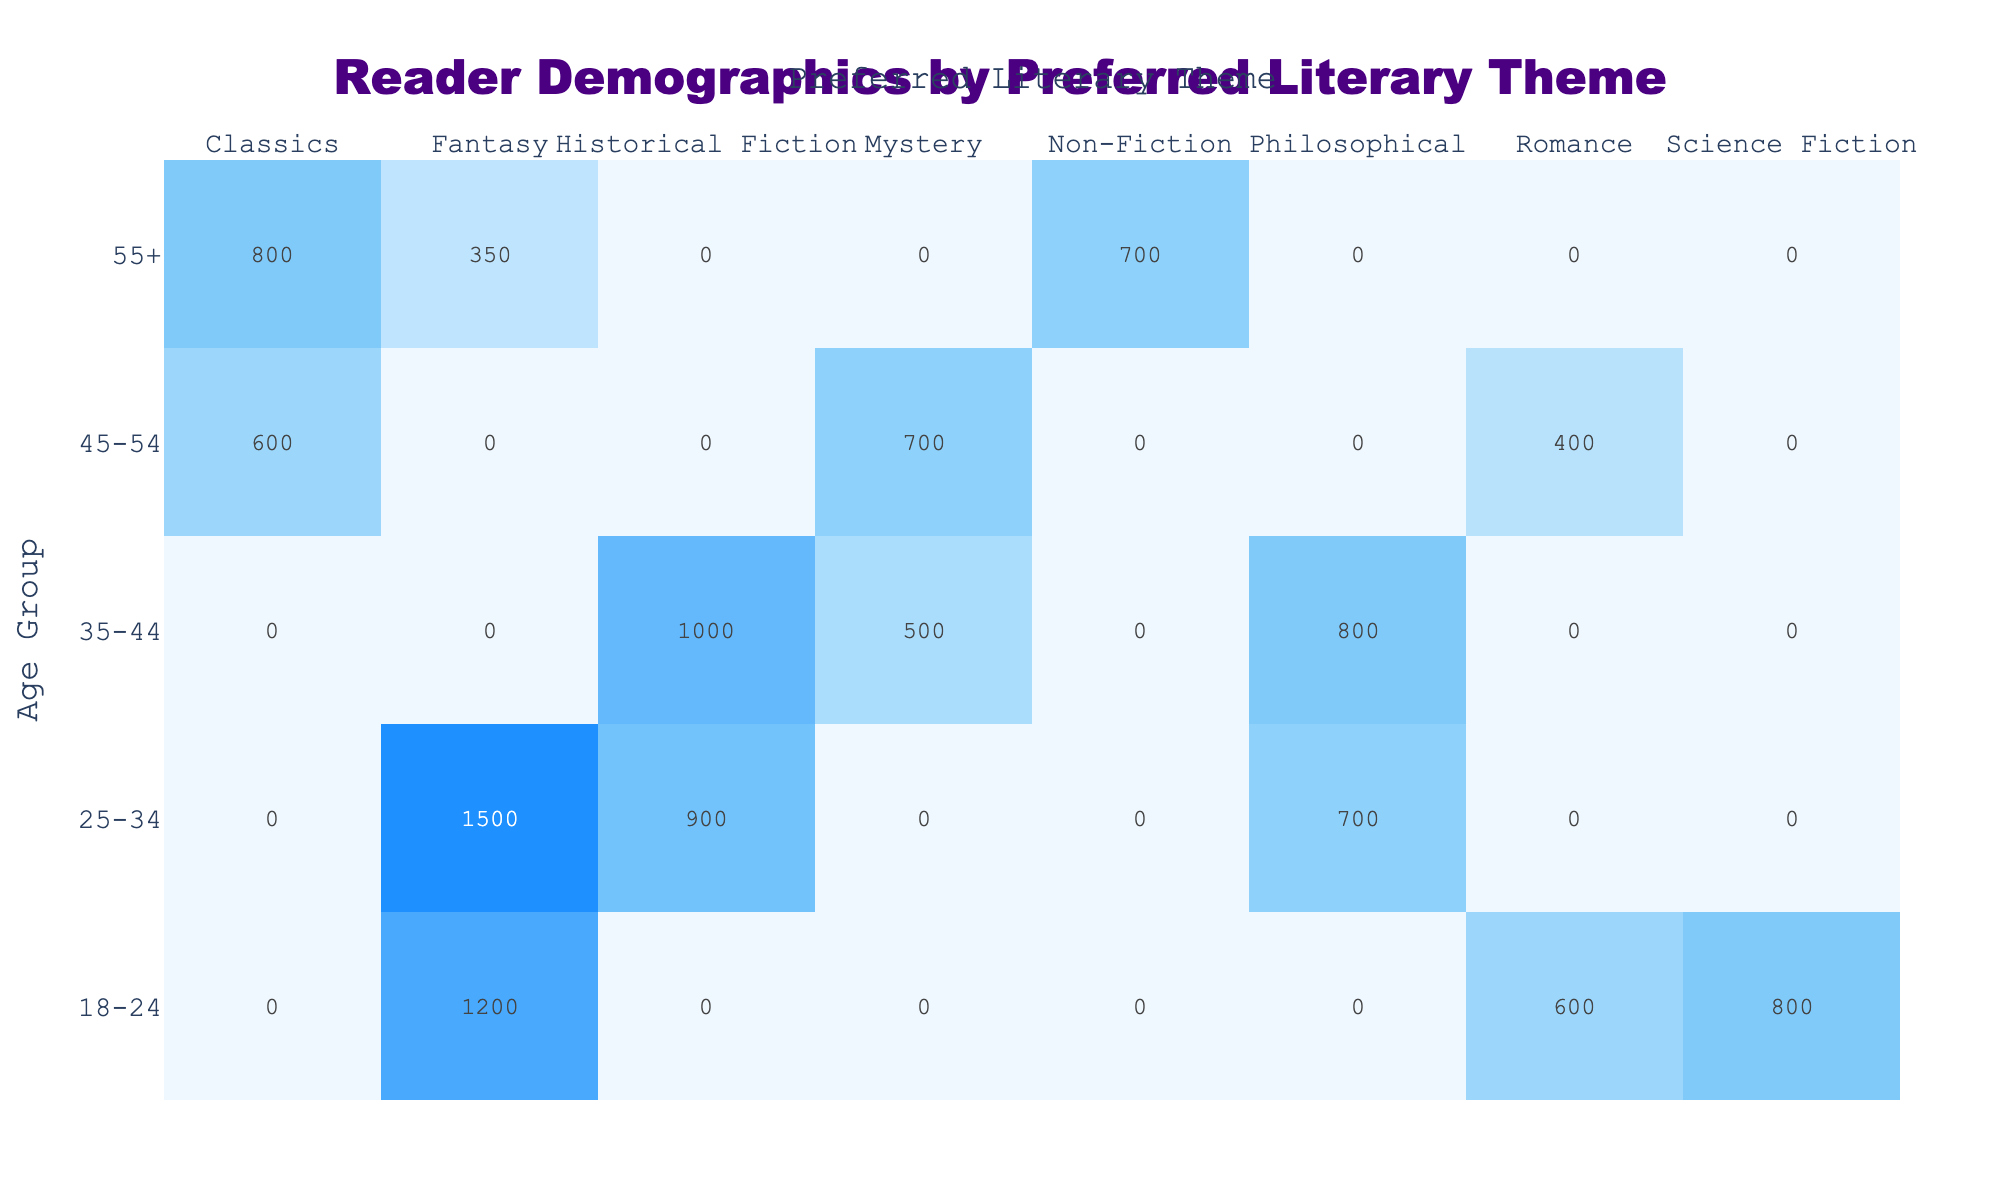What is the reader count for those aged 18-24 who prefer Fantasy? According to the table, under the Age Group 18-24 and for the Preferred Literary Theme Fantasy, the Reader Count is 1200.
Answer: 1200 Which literary theme has the highest reader count among the 25-34 age group? In the Age Group 25-34, the table shows that Fantasy has the highest Reader Count with 1500, compared to Historical Fiction (900) and Philosophical (700).
Answer: Fantasy Is it true that more readers aged 35-44 prefer Mystery than Romance? Upon checking the table, under the Age Group 35-44, the Reader Count for Mystery is 500 and for Romance, it does not appear in that age group (0). Therefore, it is true that more readers aged 35-44 prefer Mystery.
Answer: Yes What is the total number of readers for Fantasy across all age groups? To find this total, we add the Reader Counts for Fantasy across all age groups: 1200 (18-24) + 1500 (25-34) + 350 (55+) = 3050.
Answer: 3050 What is the average reader count for the Classics theme across all age groups? The provided data shows that there are two counts for Classics: 600 for the 45-54 age group and 800 for the 55+ age group. To find the average, we sum these values (600 + 800 = 1400) and divide by the number of groups (2), resulting in an average of 700.
Answer: 700 Are there more readers aged 45-54 who prefer Mystery or those aged 35-44 who prefer Historical Fiction? For the Age Group 45-54, the Reader Count for Mystery is 700, and for the Age Group 35-44, the Reader Count for Historical Fiction is 1000. Since 700 is less than 1000, it means there are fewer readers aged 45-54 preferring Mystery than those aged 35-44 preferring Historical Fiction.
Answer: No What is the difference in Reader Count for Science Fiction between age groups 18-24 and 25-34? The Reader Count for Science Fiction in the Age Group 18-24 is 800, and in the Age Group 25-34, there are no counts reported (0). Subtracting these gives us 800 - 0 = 800, which indicates that the difference is 800.
Answer: 800 Which age group has the second highest overall reader count? To determine this, we sum the reader counts for each age group: 18-24: 1200 + 800 + 600 = 2600; 25-34: 1500 + 900 + 700 = 3100; 35-44: 1000 + 800 + 500 = 2300; 45-54: 600 + 700 + 400 = 1700; 55+: 800 + 700 + 350 = 1850. The second highest overall is the 18-24 age group with 2600.
Answer: 18-24 